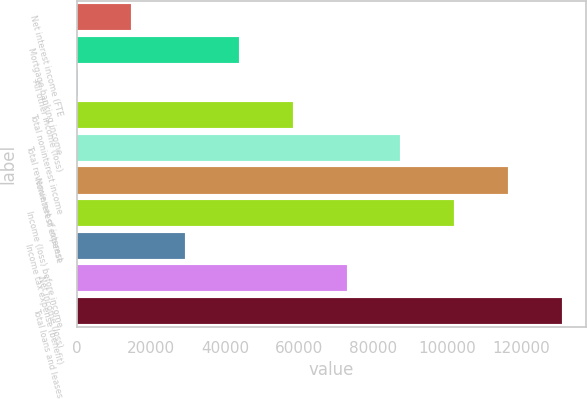<chart> <loc_0><loc_0><loc_500><loc_500><bar_chart><fcel>Net interest income (FTE<fcel>Mortgage banking income<fcel>All other income (loss)<fcel>Total noninterest income<fcel>Total revenue net of interest<fcel>Noninterest expense<fcel>Income (loss) before income<fcel>Income tax expense (benefit)<fcel>Net income (loss)<fcel>Total loans and leases<nl><fcel>14778.1<fcel>43798.3<fcel>268<fcel>58308.4<fcel>87328.6<fcel>116349<fcel>101839<fcel>29288.2<fcel>72818.5<fcel>130859<nl></chart> 